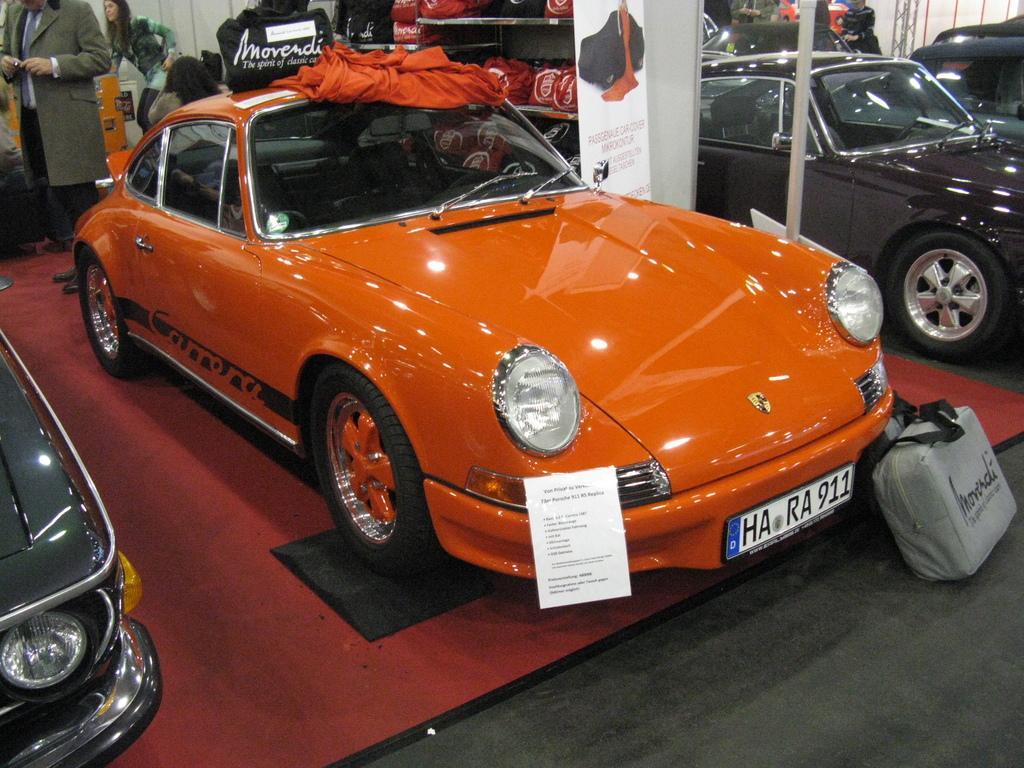How would you summarize this image in a sentence or two? In this image I can see cars and in the middle of the image there is an orange car and on top of it there is a black bag and orange cloth. In the background there are people and bags. 